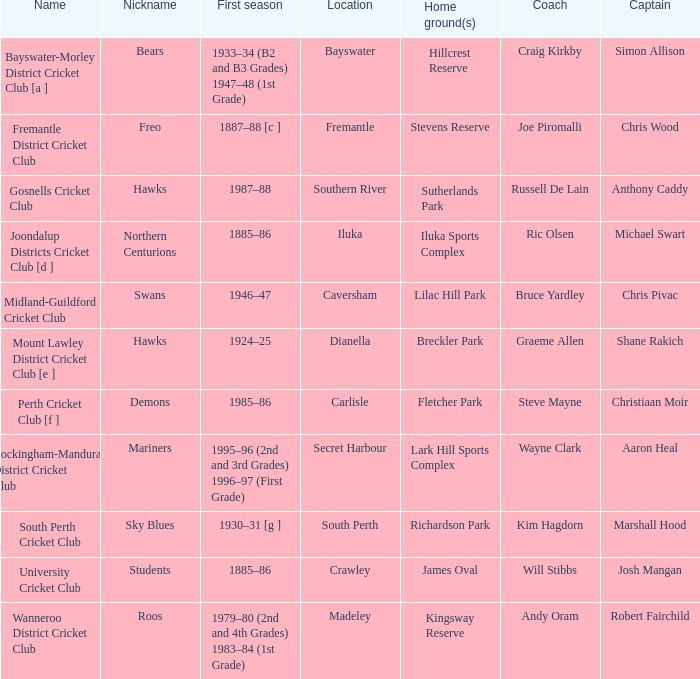What are the specific dates for hillcrest reserve being the home grounds? 1933–34 (B2 and B3 Grades) 1947–48 (1st Grade). 